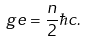Convert formula to latex. <formula><loc_0><loc_0><loc_500><loc_500>g e = \frac { n } { 2 } \hbar { c } .</formula> 